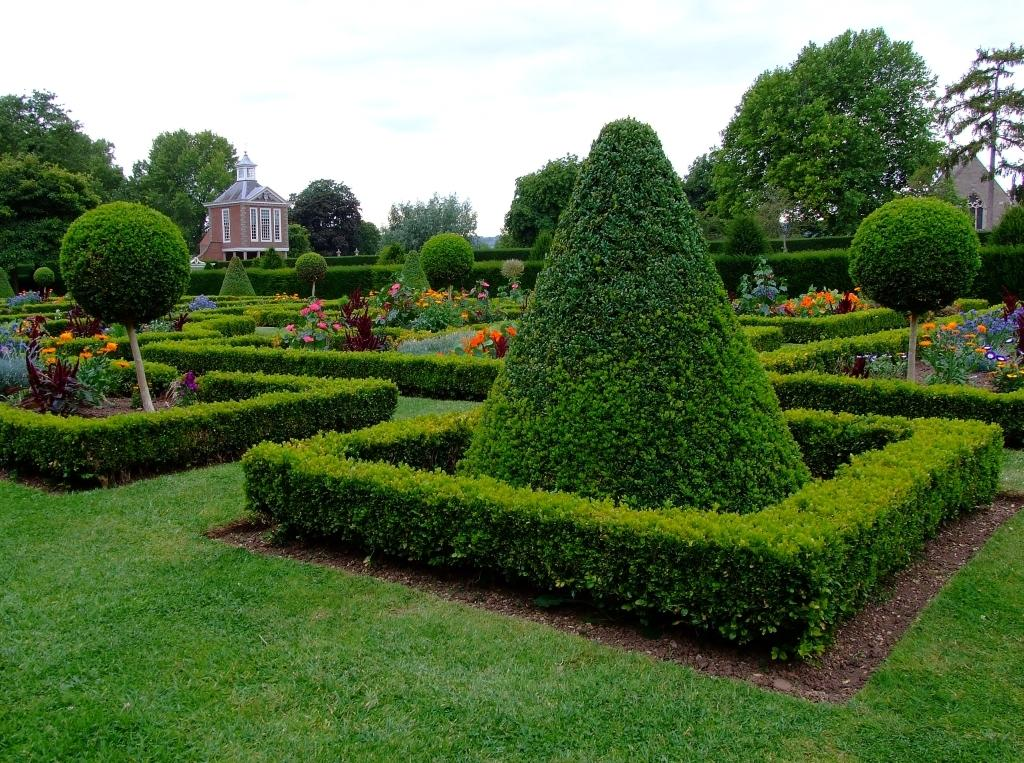Where was the image taken? The image was taken in a garden. What types of vegetation can be seen in the image? There are plants, flowers, bushes, grass, and trees in the image. What is the ground made of in the image? The ground is made of soil in the image. What can be seen in the background of the image? There are buildings and trees in the background of the image, and the sky is also visible. What type of pie is being served on the linen in the image? There is no pie or linen present in the image; it is a garden scene with various plants and trees. 